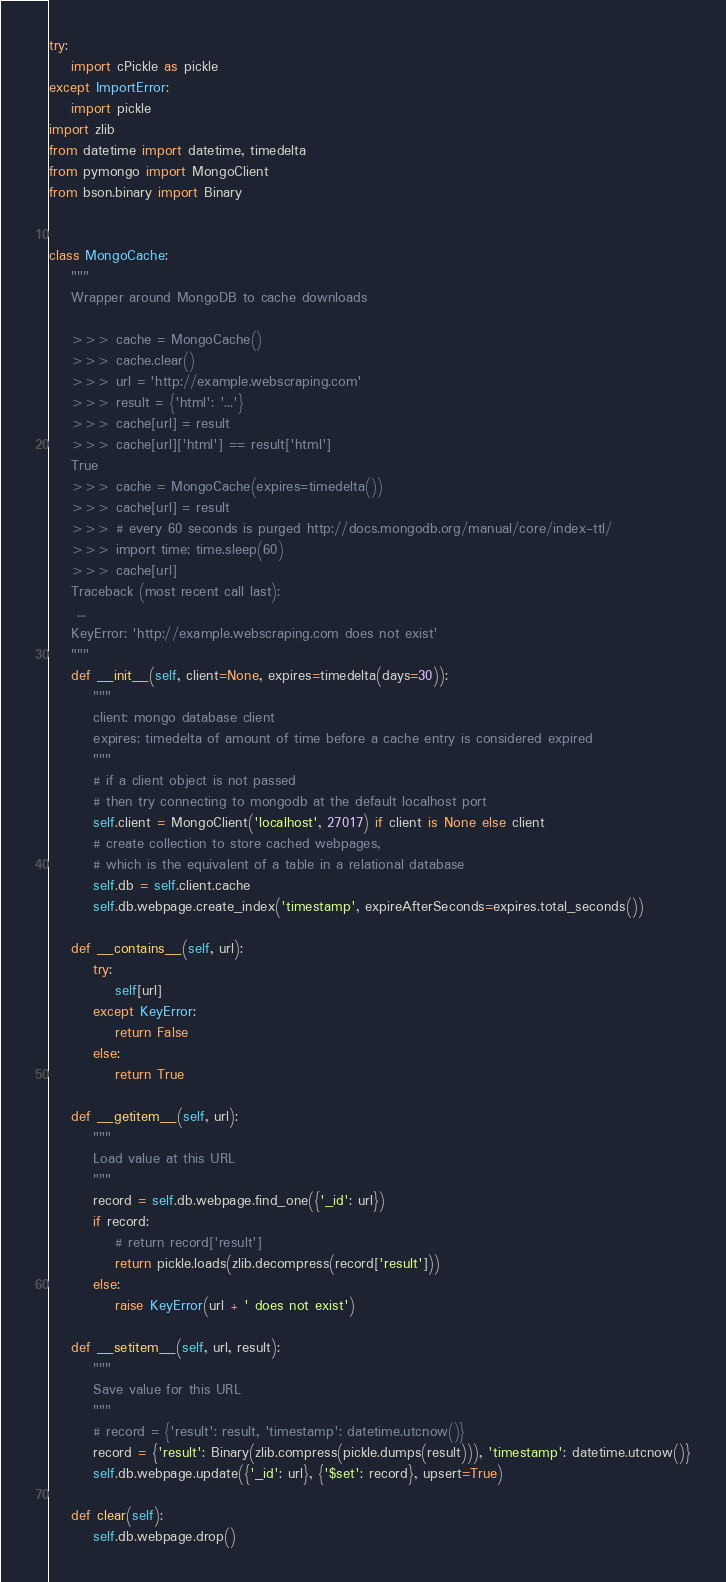<code> <loc_0><loc_0><loc_500><loc_500><_Python_>try:
    import cPickle as pickle
except ImportError:
    import pickle
import zlib
from datetime import datetime, timedelta
from pymongo import MongoClient
from bson.binary import Binary


class MongoCache:
    """
    Wrapper around MongoDB to cache downloads

    >>> cache = MongoCache()
    >>> cache.clear()
    >>> url = 'http://example.webscraping.com'
    >>> result = {'html': '...'}
    >>> cache[url] = result
    >>> cache[url]['html'] == result['html']
    True
    >>> cache = MongoCache(expires=timedelta())
    >>> cache[url] = result
    >>> # every 60 seconds is purged http://docs.mongodb.org/manual/core/index-ttl/
    >>> import time; time.sleep(60)
    >>> cache[url]
    Traceback (most recent call last):
     ...
    KeyError: 'http://example.webscraping.com does not exist'
    """
    def __init__(self, client=None, expires=timedelta(days=30)):
        """
        client: mongo database client
        expires: timedelta of amount of time before a cache entry is considered expired
        """
        # if a client object is not passed
        # then try connecting to mongodb at the default localhost port
        self.client = MongoClient('localhost', 27017) if client is None else client
        # create collection to store cached webpages,
        # which is the equivalent of a table in a relational database
        self.db = self.client.cache
        self.db.webpage.create_index('timestamp', expireAfterSeconds=expires.total_seconds())

    def __contains__(self, url):
        try:
            self[url]
        except KeyError:
            return False
        else:
            return True

    def __getitem__(self, url):
        """
        Load value at this URL
        """
        record = self.db.webpage.find_one({'_id': url})
        if record:
            # return record['result']
            return pickle.loads(zlib.decompress(record['result']))
        else:
            raise KeyError(url + ' does not exist')

    def __setitem__(self, url, result):
        """
        Save value for this URL
        """
        # record = {'result': result, 'timestamp': datetime.utcnow()}
        record = {'result': Binary(zlib.compress(pickle.dumps(result))), 'timestamp': datetime.utcnow()}
        self.db.webpage.update({'_id': url}, {'$set': record}, upsert=True)

    def clear(self):
        self.db.webpage.drop()
</code> 